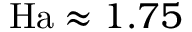<formula> <loc_0><loc_0><loc_500><loc_500>H a \approx 1 . 7 5</formula> 